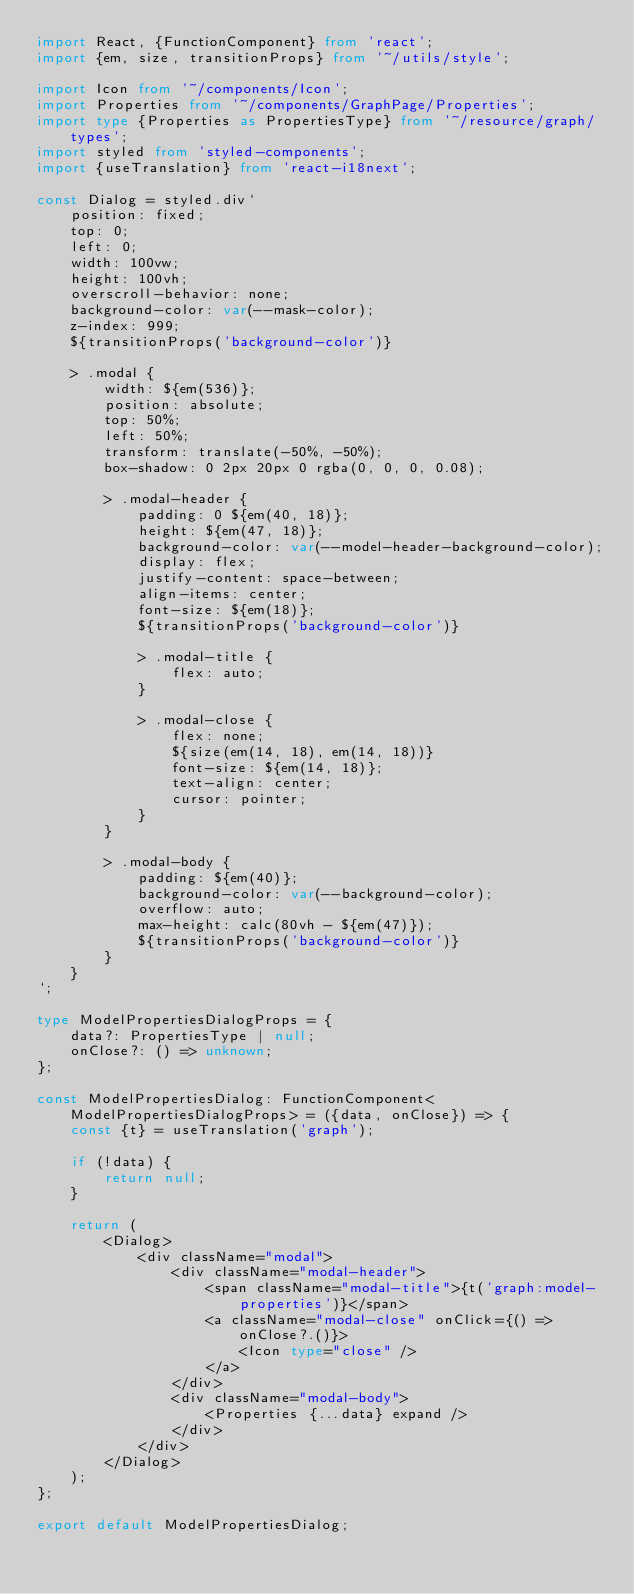<code> <loc_0><loc_0><loc_500><loc_500><_TypeScript_>import React, {FunctionComponent} from 'react';
import {em, size, transitionProps} from '~/utils/style';

import Icon from '~/components/Icon';
import Properties from '~/components/GraphPage/Properties';
import type {Properties as PropertiesType} from '~/resource/graph/types';
import styled from 'styled-components';
import {useTranslation} from 'react-i18next';

const Dialog = styled.div`
    position: fixed;
    top: 0;
    left: 0;
    width: 100vw;
    height: 100vh;
    overscroll-behavior: none;
    background-color: var(--mask-color);
    z-index: 999;
    ${transitionProps('background-color')}

    > .modal {
        width: ${em(536)};
        position: absolute;
        top: 50%;
        left: 50%;
        transform: translate(-50%, -50%);
        box-shadow: 0 2px 20px 0 rgba(0, 0, 0, 0.08);

        > .modal-header {
            padding: 0 ${em(40, 18)};
            height: ${em(47, 18)};
            background-color: var(--model-header-background-color);
            display: flex;
            justify-content: space-between;
            align-items: center;
            font-size: ${em(18)};
            ${transitionProps('background-color')}

            > .modal-title {
                flex: auto;
            }

            > .modal-close {
                flex: none;
                ${size(em(14, 18), em(14, 18))}
                font-size: ${em(14, 18)};
                text-align: center;
                cursor: pointer;
            }
        }

        > .modal-body {
            padding: ${em(40)};
            background-color: var(--background-color);
            overflow: auto;
            max-height: calc(80vh - ${em(47)});
            ${transitionProps('background-color')}
        }
    }
`;

type ModelPropertiesDialogProps = {
    data?: PropertiesType | null;
    onClose?: () => unknown;
};

const ModelPropertiesDialog: FunctionComponent<ModelPropertiesDialogProps> = ({data, onClose}) => {
    const {t} = useTranslation('graph');

    if (!data) {
        return null;
    }

    return (
        <Dialog>
            <div className="modal">
                <div className="modal-header">
                    <span className="modal-title">{t('graph:model-properties')}</span>
                    <a className="modal-close" onClick={() => onClose?.()}>
                        <Icon type="close" />
                    </a>
                </div>
                <div className="modal-body">
                    <Properties {...data} expand />
                </div>
            </div>
        </Dialog>
    );
};

export default ModelPropertiesDialog;
</code> 